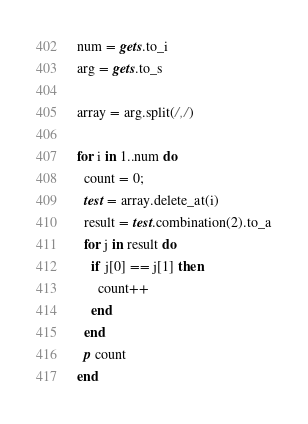<code> <loc_0><loc_0><loc_500><loc_500><_Ruby_>num = gets.to_i
arg = gets.to_s

array = arg.split(/,/)

for i in 1..num do
  count = 0;
  test = array.delete_at(i)
  result = test.combination(2).to_a
  for j in result do
    if j[0] == j[1] then
      count++
    end
  end
  p count
end

</code> 